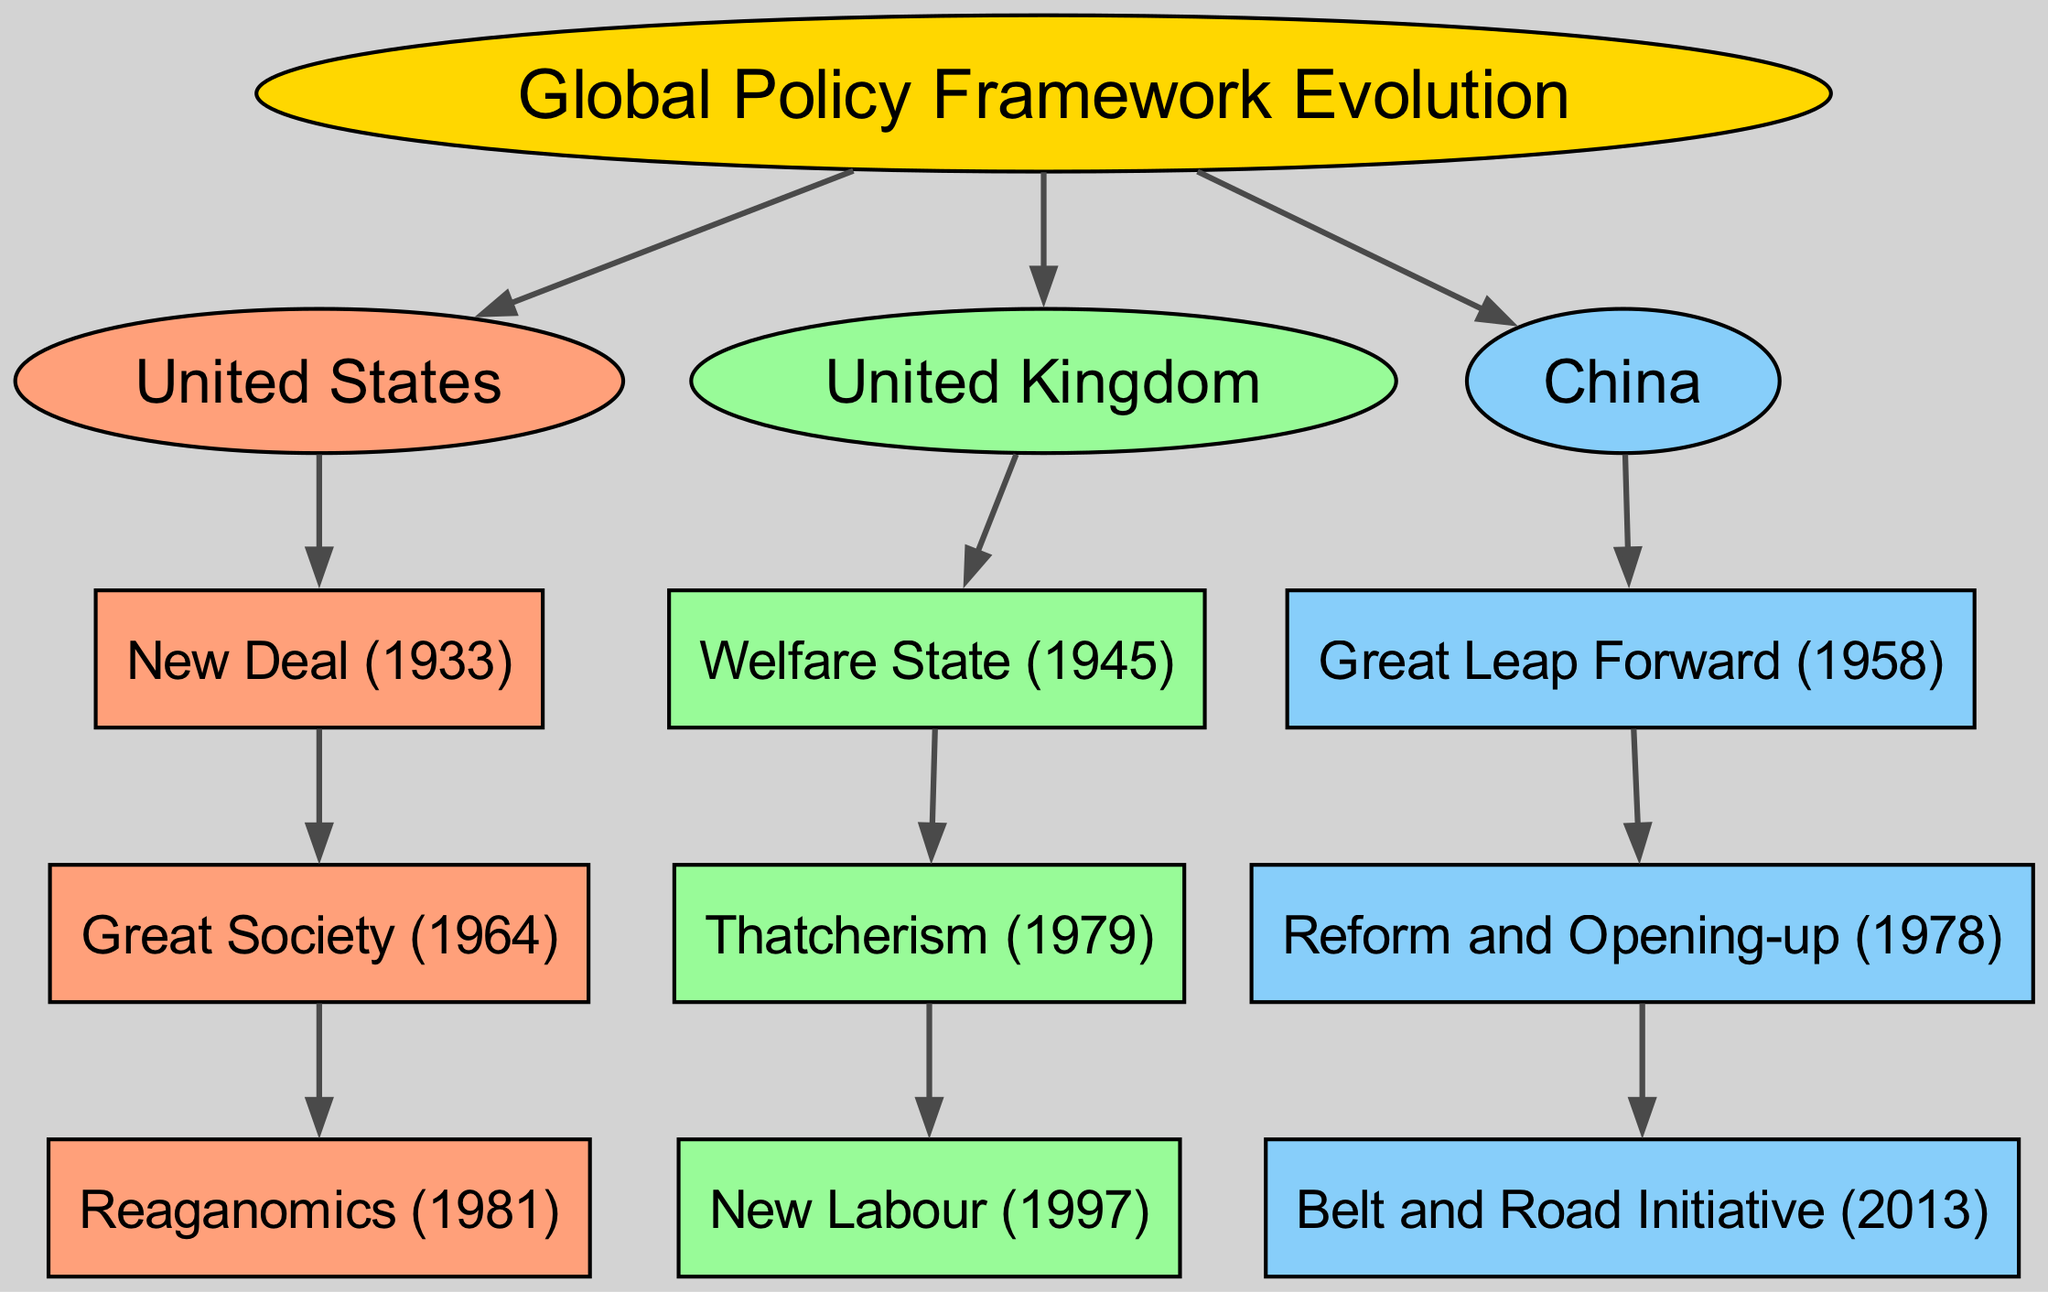What is the root of the family tree? The root of the family tree is labeled "Global Policy Framework Evolution," which serves as the starting point for all branches that depict various nations' policy frameworks.
Answer: Global Policy Framework Evolution How many main countries are represented in the diagram? The diagram contains three main country branches: the United States, the United Kingdom, and China, indicating the countries analyzed in relation to their policy frameworks.
Answer: 3 Which policy framework follows the New Deal in the United States? The diagram indicates that the "Great Society," implemented in 1964, directly follows the "New Deal," which began in 1933, as a part of the evolution of policies in the United States.
Answer: Great Society What year did the Great Leap Forward begin in China? According to the diagram, the "Great Leap Forward" initiated in China in 1958, marking a significant point in China's policy evolution.
Answer: 1958 Which policy followed Thatcherism in the United Kingdom? The "New Labour" policy succeeded "Thatcherism" in 1997 according to the diagram, indicating a progression in the United Kingdom's approach to policy after Thatcher's economic reforms.
Answer: New Labour Which country introduced the Belt and Road Initiative? The diagram shows that the "Belt and Road Initiative," which started in 2013, is a development under China, highlighting contemporary policy framework evolution.
Answer: China What is the first policy framework in the United Kingdom? The first policy framework listed in the United Kingdom branch is the "Welfare State," which was established in 1945, symbolizing post-war social reforms.
Answer: Welfare State How many policies are linked under the United States branch? There are three different policies connected under the United States branch: New Deal, Great Society, and Reaganomics, showing the evolution of U.S. policy over time.
Answer: 3 What type of diagram is used to represent global policy framework evolution? The diagram is a family tree, structured to depict the lineage and progression of various policy frameworks across different nations clearly.
Answer: Family tree 